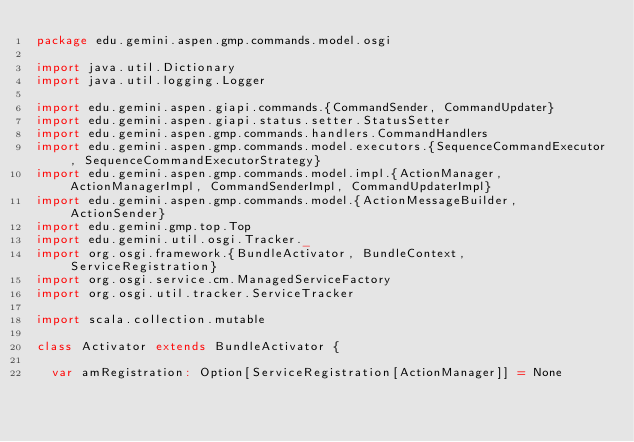<code> <loc_0><loc_0><loc_500><loc_500><_Scala_>package edu.gemini.aspen.gmp.commands.model.osgi

import java.util.Dictionary
import java.util.logging.Logger

import edu.gemini.aspen.giapi.commands.{CommandSender, CommandUpdater}
import edu.gemini.aspen.giapi.status.setter.StatusSetter
import edu.gemini.aspen.gmp.commands.handlers.CommandHandlers
import edu.gemini.aspen.gmp.commands.model.executors.{SequenceCommandExecutor, SequenceCommandExecutorStrategy}
import edu.gemini.aspen.gmp.commands.model.impl.{ActionManager, ActionManagerImpl, CommandSenderImpl, CommandUpdaterImpl}
import edu.gemini.aspen.gmp.commands.model.{ActionMessageBuilder, ActionSender}
import edu.gemini.gmp.top.Top
import edu.gemini.util.osgi.Tracker._
import org.osgi.framework.{BundleActivator, BundleContext, ServiceRegistration}
import org.osgi.service.cm.ManagedServiceFactory
import org.osgi.util.tracker.ServiceTracker

import scala.collection.mutable

class Activator extends BundleActivator {

  var amRegistration: Option[ServiceRegistration[ActionManager]] = None</code> 